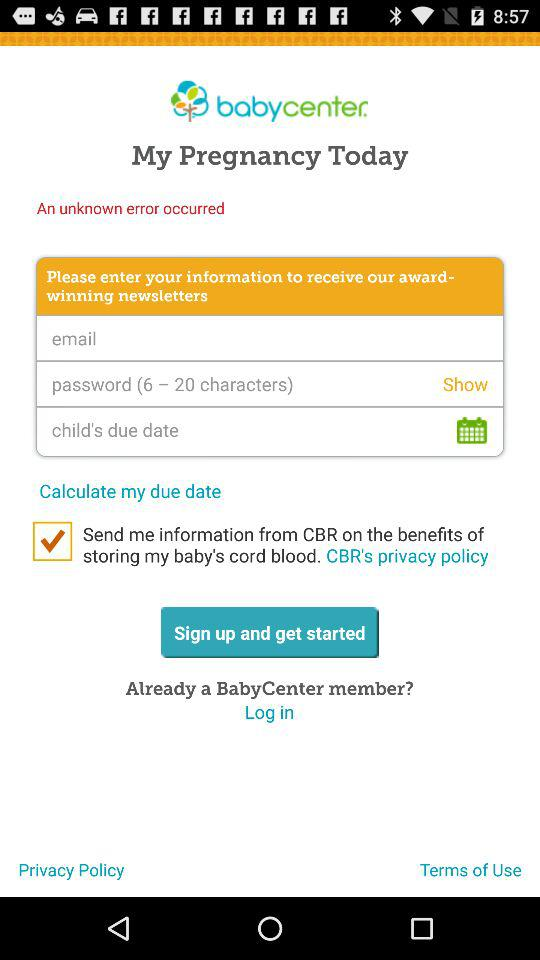What is the status of "Send me information from CBR on the benefits of storing my baby's cord blood. CBR's privacy policy"? The status is "on". 